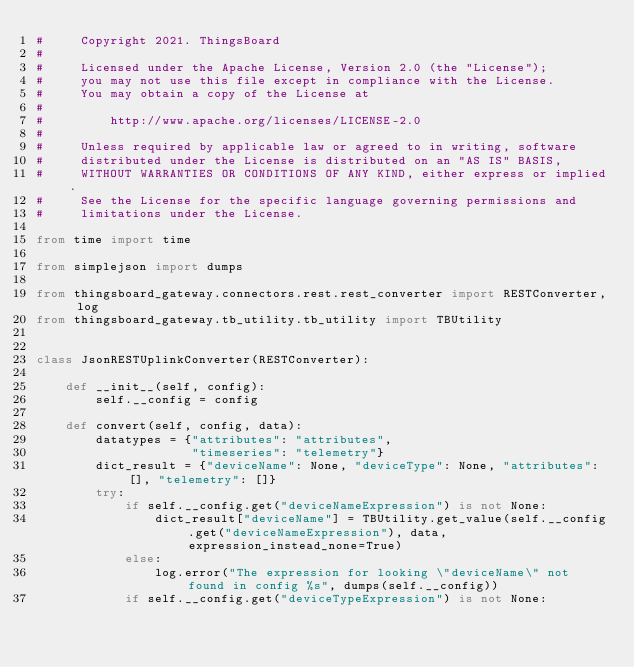Convert code to text. <code><loc_0><loc_0><loc_500><loc_500><_Python_>#     Copyright 2021. ThingsBoard
#
#     Licensed under the Apache License, Version 2.0 (the "License");
#     you may not use this file except in compliance with the License.
#     You may obtain a copy of the License at
#
#         http://www.apache.org/licenses/LICENSE-2.0
#
#     Unless required by applicable law or agreed to in writing, software
#     distributed under the License is distributed on an "AS IS" BASIS,
#     WITHOUT WARRANTIES OR CONDITIONS OF ANY KIND, either express or implied.
#     See the License for the specific language governing permissions and
#     limitations under the License.

from time import time

from simplejson import dumps

from thingsboard_gateway.connectors.rest.rest_converter import RESTConverter, log
from thingsboard_gateway.tb_utility.tb_utility import TBUtility


class JsonRESTUplinkConverter(RESTConverter):

    def __init__(self, config):
        self.__config = config

    def convert(self, config, data):
        datatypes = {"attributes": "attributes",
                     "timeseries": "telemetry"}
        dict_result = {"deviceName": None, "deviceType": None, "attributes": [], "telemetry": []}
        try:
            if self.__config.get("deviceNameExpression") is not None:
                dict_result["deviceName"] = TBUtility.get_value(self.__config.get("deviceNameExpression"), data, expression_instead_none=True)
            else:
                log.error("The expression for looking \"deviceName\" not found in config %s", dumps(self.__config))
            if self.__config.get("deviceTypeExpression") is not None:</code> 